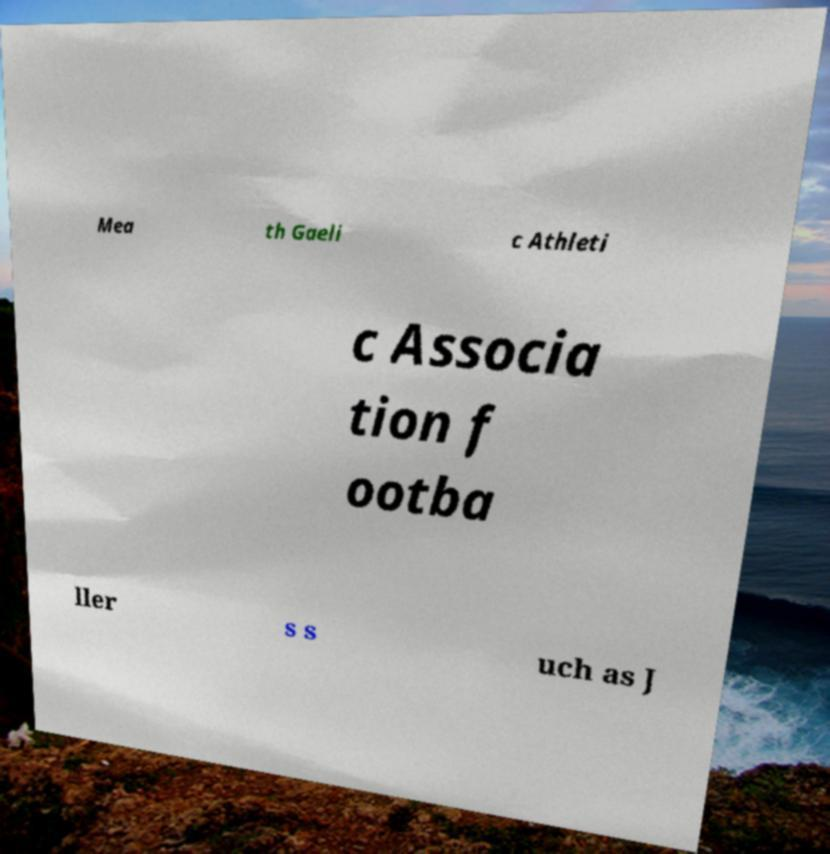Could you extract and type out the text from this image? Mea th Gaeli c Athleti c Associa tion f ootba ller s s uch as J 